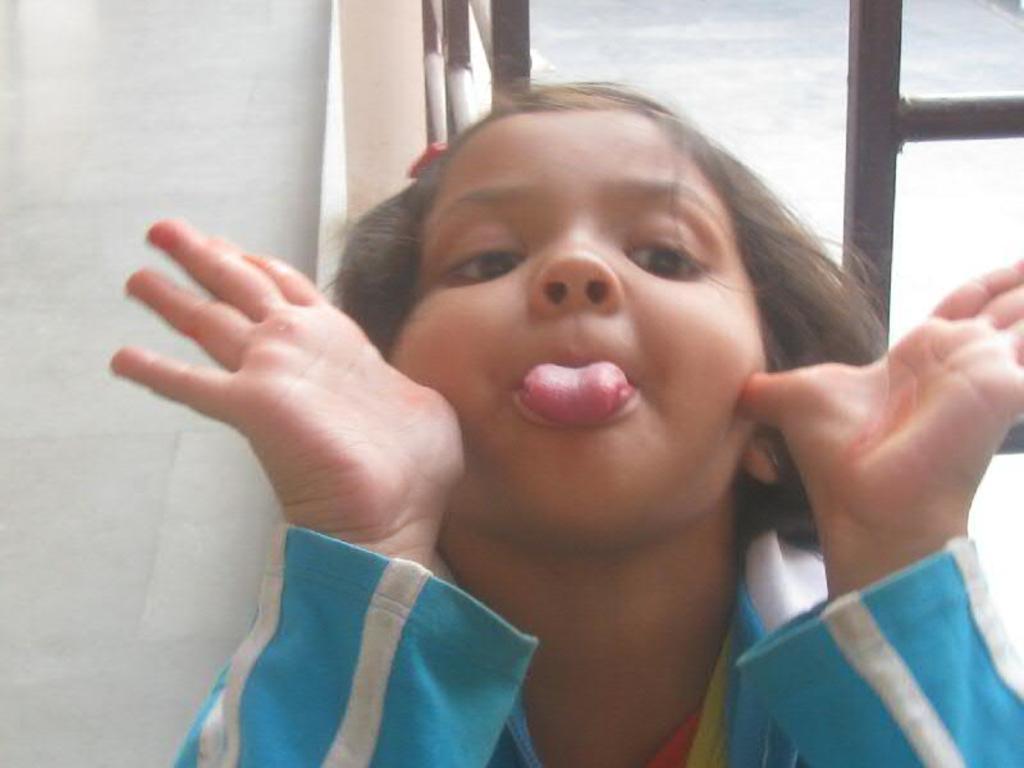Could you give a brief overview of what you see in this image? In which image in the center there is a girl. In the background there is a window. 